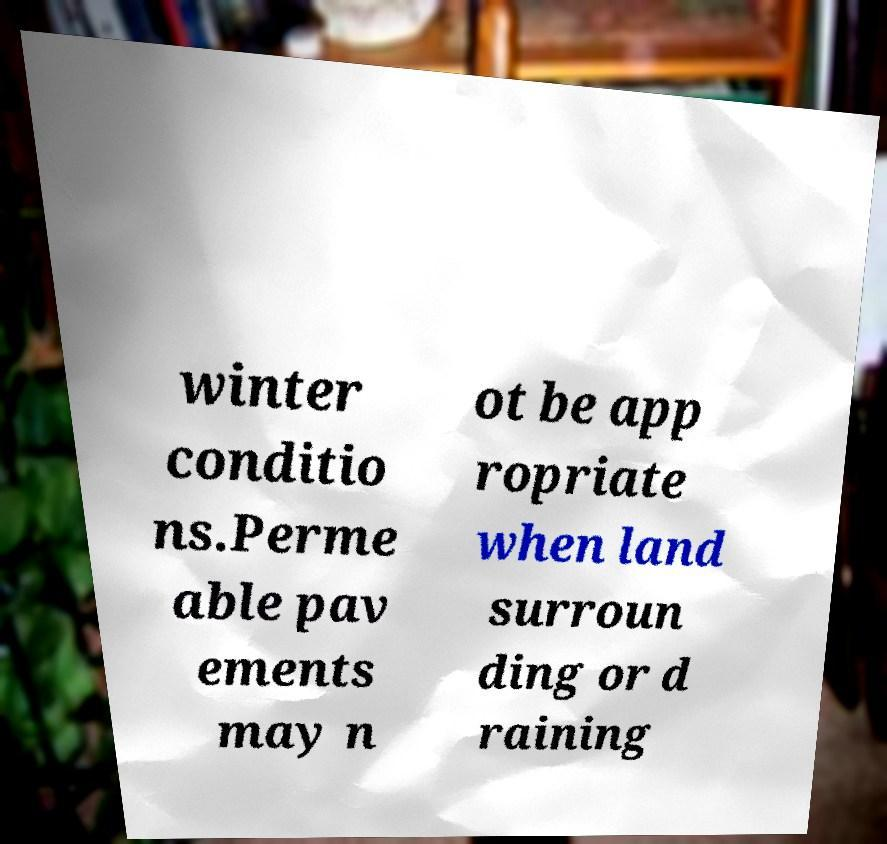What messages or text are displayed in this image? I need them in a readable, typed format. winter conditio ns.Perme able pav ements may n ot be app ropriate when land surroun ding or d raining 